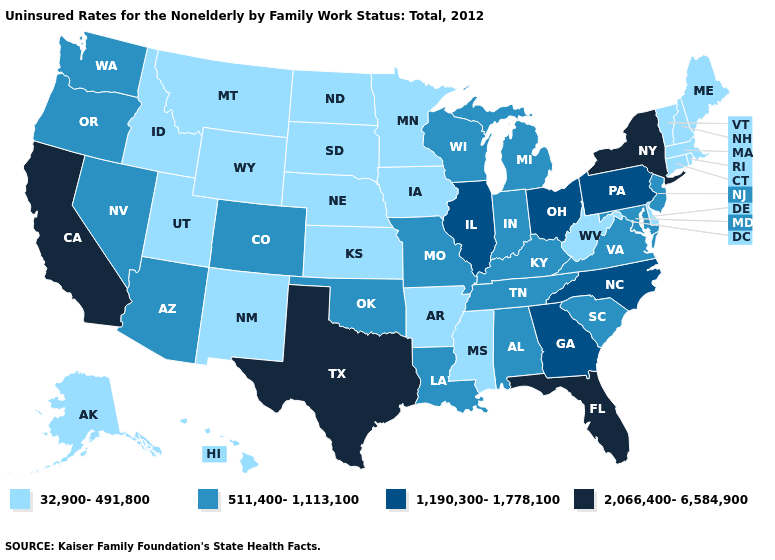What is the value of South Carolina?
Quick response, please. 511,400-1,113,100. Does Florida have a higher value than New York?
Quick response, please. No. What is the value of Arkansas?
Write a very short answer. 32,900-491,800. Name the states that have a value in the range 1,190,300-1,778,100?
Be succinct. Georgia, Illinois, North Carolina, Ohio, Pennsylvania. Name the states that have a value in the range 2,066,400-6,584,900?
Short answer required. California, Florida, New York, Texas. Which states have the lowest value in the USA?
Concise answer only. Alaska, Arkansas, Connecticut, Delaware, Hawaii, Idaho, Iowa, Kansas, Maine, Massachusetts, Minnesota, Mississippi, Montana, Nebraska, New Hampshire, New Mexico, North Dakota, Rhode Island, South Dakota, Utah, Vermont, West Virginia, Wyoming. Which states hav the highest value in the South?
Give a very brief answer. Florida, Texas. Does New York have the highest value in the USA?
Short answer required. Yes. What is the value of South Carolina?
Give a very brief answer. 511,400-1,113,100. Does the first symbol in the legend represent the smallest category?
Write a very short answer. Yes. What is the highest value in the West ?
Concise answer only. 2,066,400-6,584,900. Does Florida have the highest value in the USA?
Answer briefly. Yes. Which states have the highest value in the USA?
Give a very brief answer. California, Florida, New York, Texas. Among the states that border South Dakota , which have the lowest value?
Be succinct. Iowa, Minnesota, Montana, Nebraska, North Dakota, Wyoming. Name the states that have a value in the range 1,190,300-1,778,100?
Short answer required. Georgia, Illinois, North Carolina, Ohio, Pennsylvania. 